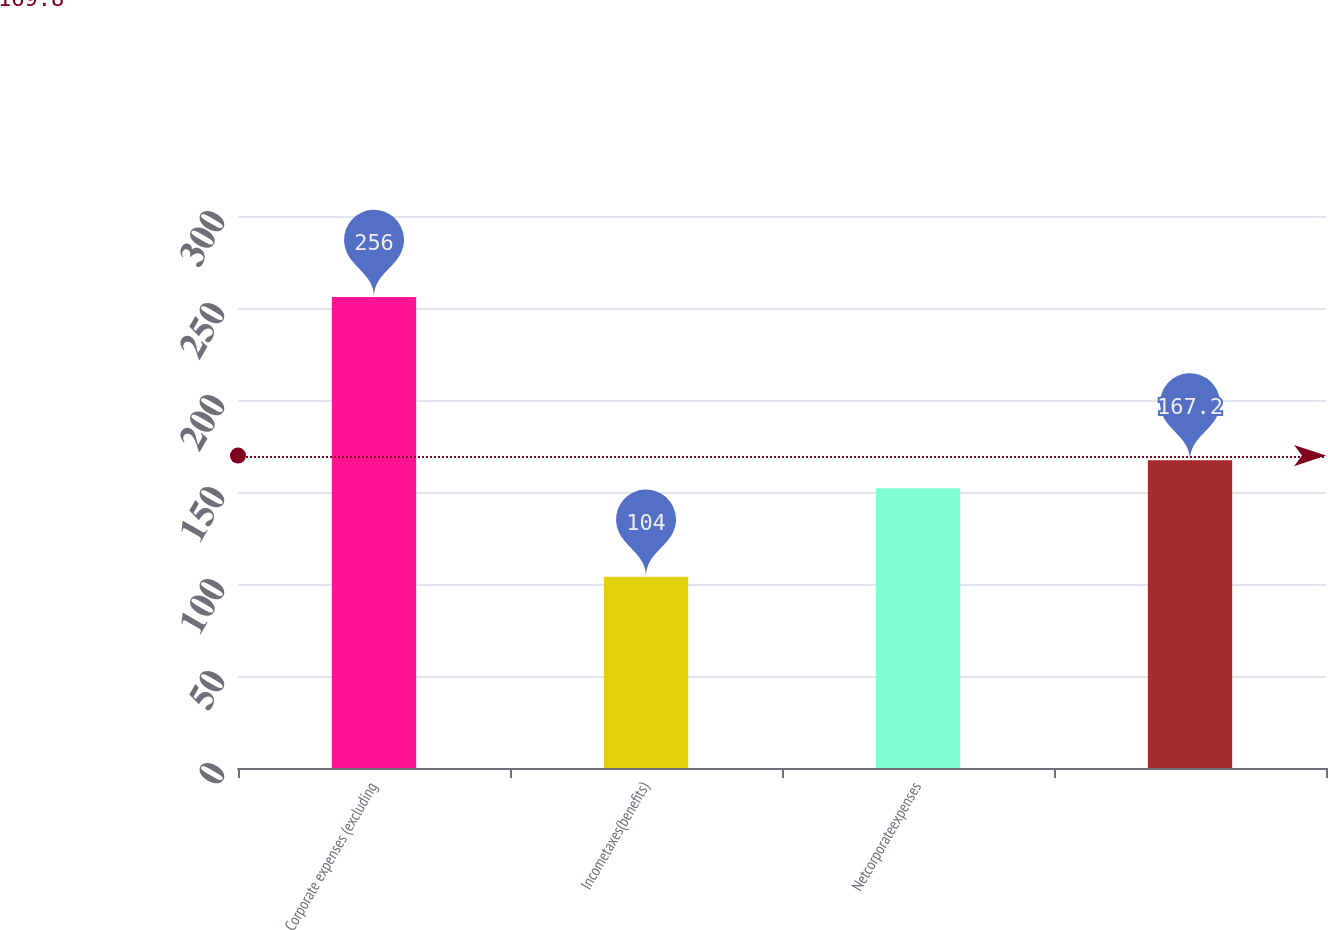Convert chart to OTSL. <chart><loc_0><loc_0><loc_500><loc_500><bar_chart><fcel>Corporate expenses (excluding<fcel>Incometaxes(benefits)<fcel>Netcorporateexpenses<fcel>Unnamed: 3<nl><fcel>256<fcel>104<fcel>152<fcel>167.2<nl></chart> 